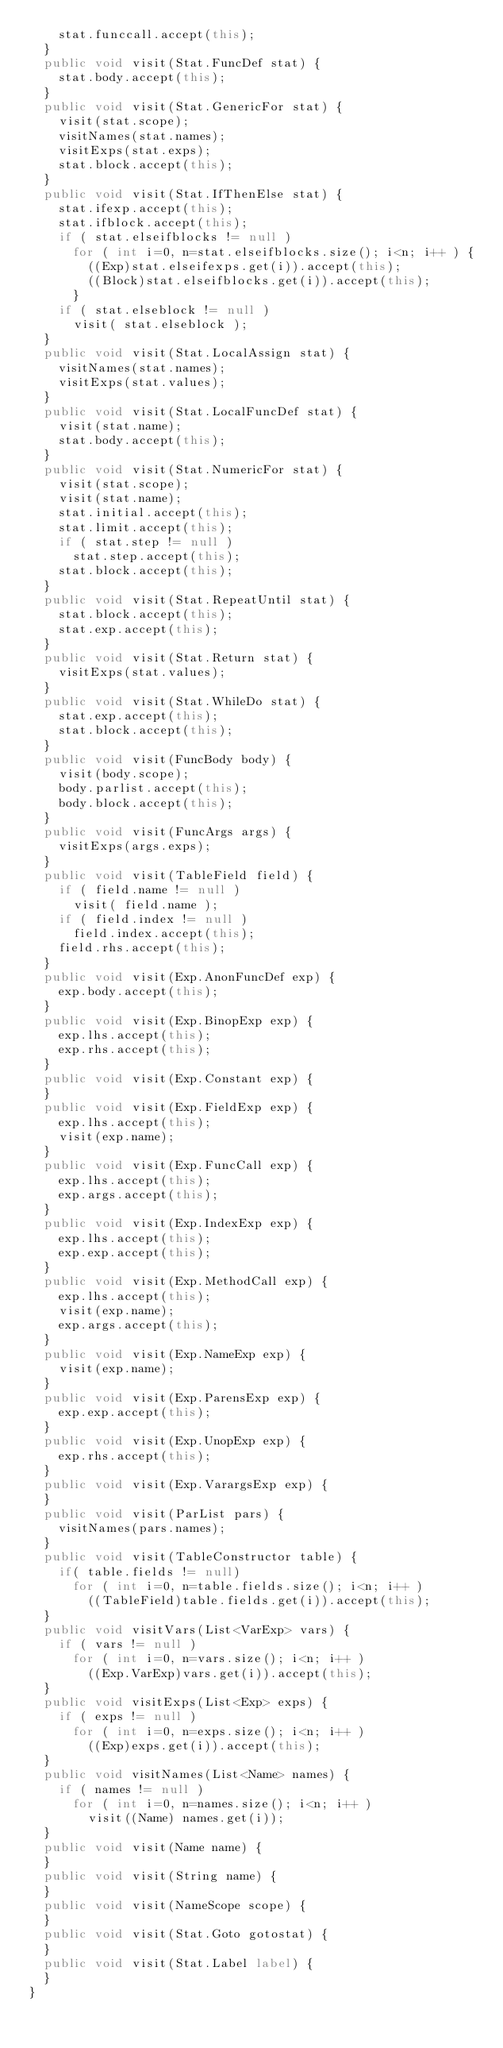Convert code to text. <code><loc_0><loc_0><loc_500><loc_500><_Java_>		stat.funccall.accept(this);
	}
	public void visit(Stat.FuncDef stat) {
		stat.body.accept(this);
	}
	public void visit(Stat.GenericFor stat) {
		visit(stat.scope);
		visitNames(stat.names);
		visitExps(stat.exps);
		stat.block.accept(this);
	}
	public void visit(Stat.IfThenElse stat) {
		stat.ifexp.accept(this);
		stat.ifblock.accept(this);
		if ( stat.elseifblocks != null ) 
			for ( int i=0, n=stat.elseifblocks.size(); i<n; i++ ) {
				((Exp)stat.elseifexps.get(i)).accept(this);
				((Block)stat.elseifblocks.get(i)).accept(this);
			}
		if ( stat.elseblock != null )
			visit( stat.elseblock );
	}
	public void visit(Stat.LocalAssign stat) {
		visitNames(stat.names);
		visitExps(stat.values);
	}
	public void visit(Stat.LocalFuncDef stat) {
		visit(stat.name);
		stat.body.accept(this);
	}
	public void visit(Stat.NumericFor stat) {
		visit(stat.scope);
		visit(stat.name);
		stat.initial.accept(this);
		stat.limit.accept(this);
		if ( stat.step != null )
			stat.step.accept(this);
		stat.block.accept(this);
	}
	public void visit(Stat.RepeatUntil stat) {
		stat.block.accept(this);
		stat.exp.accept(this);
	}
	public void visit(Stat.Return stat) {
		visitExps(stat.values);
	}
	public void visit(Stat.WhileDo stat) {
		stat.exp.accept(this);
		stat.block.accept(this);
	}
	public void visit(FuncBody body) {
		visit(body.scope);
		body.parlist.accept(this);
		body.block.accept(this);
	}
	public void visit(FuncArgs args) {
		visitExps(args.exps);
	}
	public void visit(TableField field) {
		if ( field.name != null )
			visit( field.name );
		if ( field.index != null )
			field.index.accept(this);
		field.rhs.accept(this);
	}
	public void visit(Exp.AnonFuncDef exp) {
		exp.body.accept(this);
	}
	public void visit(Exp.BinopExp exp) {
		exp.lhs.accept(this);
		exp.rhs.accept(this);
	}
	public void visit(Exp.Constant exp) {
	}
	public void visit(Exp.FieldExp exp) {
		exp.lhs.accept(this);
		visit(exp.name);
	}
	public void visit(Exp.FuncCall exp) {
		exp.lhs.accept(this);
		exp.args.accept(this);
	}
	public void visit(Exp.IndexExp exp) {
		exp.lhs.accept(this);
		exp.exp.accept(this);
	}
	public void visit(Exp.MethodCall exp) {
		exp.lhs.accept(this);
		visit(exp.name);
		exp.args.accept(this);
	}
	public void visit(Exp.NameExp exp) {
		visit(exp.name);
	}
	public void visit(Exp.ParensExp exp) {
		exp.exp.accept(this);
	}
	public void visit(Exp.UnopExp exp) {
		exp.rhs.accept(this);
	}
	public void visit(Exp.VarargsExp exp) {
	}
	public void visit(ParList pars) {
		visitNames(pars.names);
	}
	public void visit(TableConstructor table) {
		if( table.fields != null)
			for ( int i=0, n=table.fields.size(); i<n; i++ )
				((TableField)table.fields.get(i)).accept(this);
	}
	public void visitVars(List<VarExp> vars) {
		if ( vars != null )
			for ( int i=0, n=vars.size(); i<n; i++ )
				((Exp.VarExp)vars.get(i)).accept(this);
	}
	public void visitExps(List<Exp> exps) {
		if ( exps != null )
			for ( int i=0, n=exps.size(); i<n; i++ )
				((Exp)exps.get(i)).accept(this);
	}
	public void visitNames(List<Name> names) {
		if ( names != null )
			for ( int i=0, n=names.size(); i<n; i++ )
				visit((Name) names.get(i));
	}
	public void visit(Name name) {
	}
	public void visit(String name) {
	}
	public void visit(NameScope scope) {
	}
	public void visit(Stat.Goto gotostat) {
	}
	public void visit(Stat.Label label) {
	}
}
</code> 